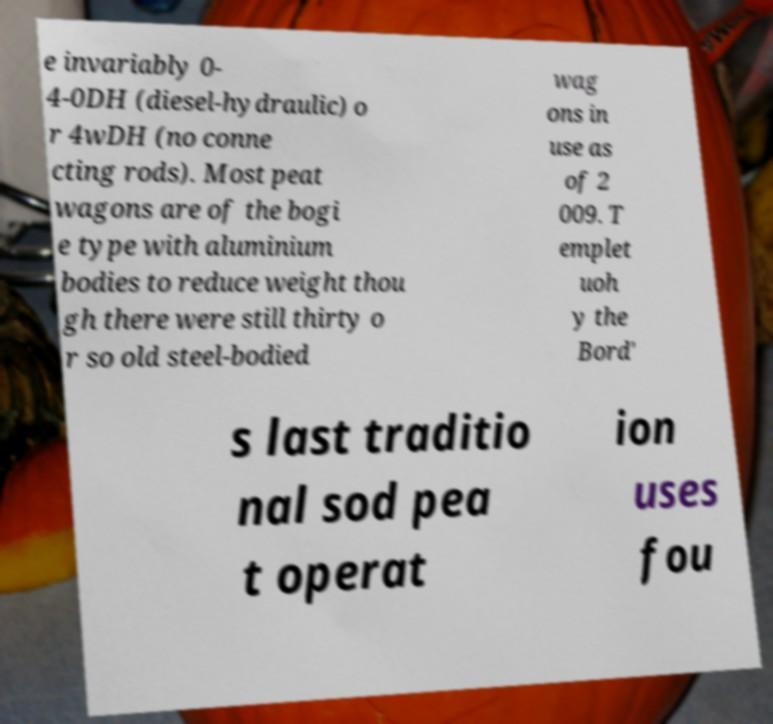I need the written content from this picture converted into text. Can you do that? e invariably 0- 4-0DH (diesel-hydraulic) o r 4wDH (no conne cting rods). Most peat wagons are of the bogi e type with aluminium bodies to reduce weight thou gh there were still thirty o r so old steel-bodied wag ons in use as of 2 009. T emplet uoh y the Bord' s last traditio nal sod pea t operat ion uses fou 